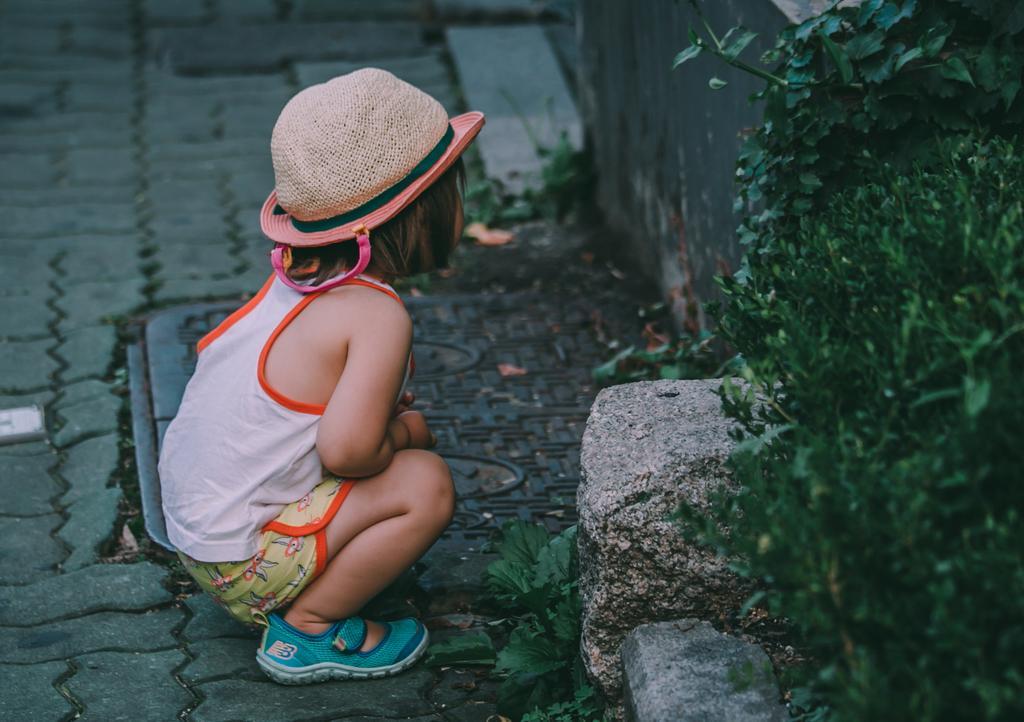In one or two sentences, can you explain what this image depicts? In the image there is a baby girl,she is sitting on the floor in a squatting position,in front of the girl there is a wall and beside the wall there are some plants. 